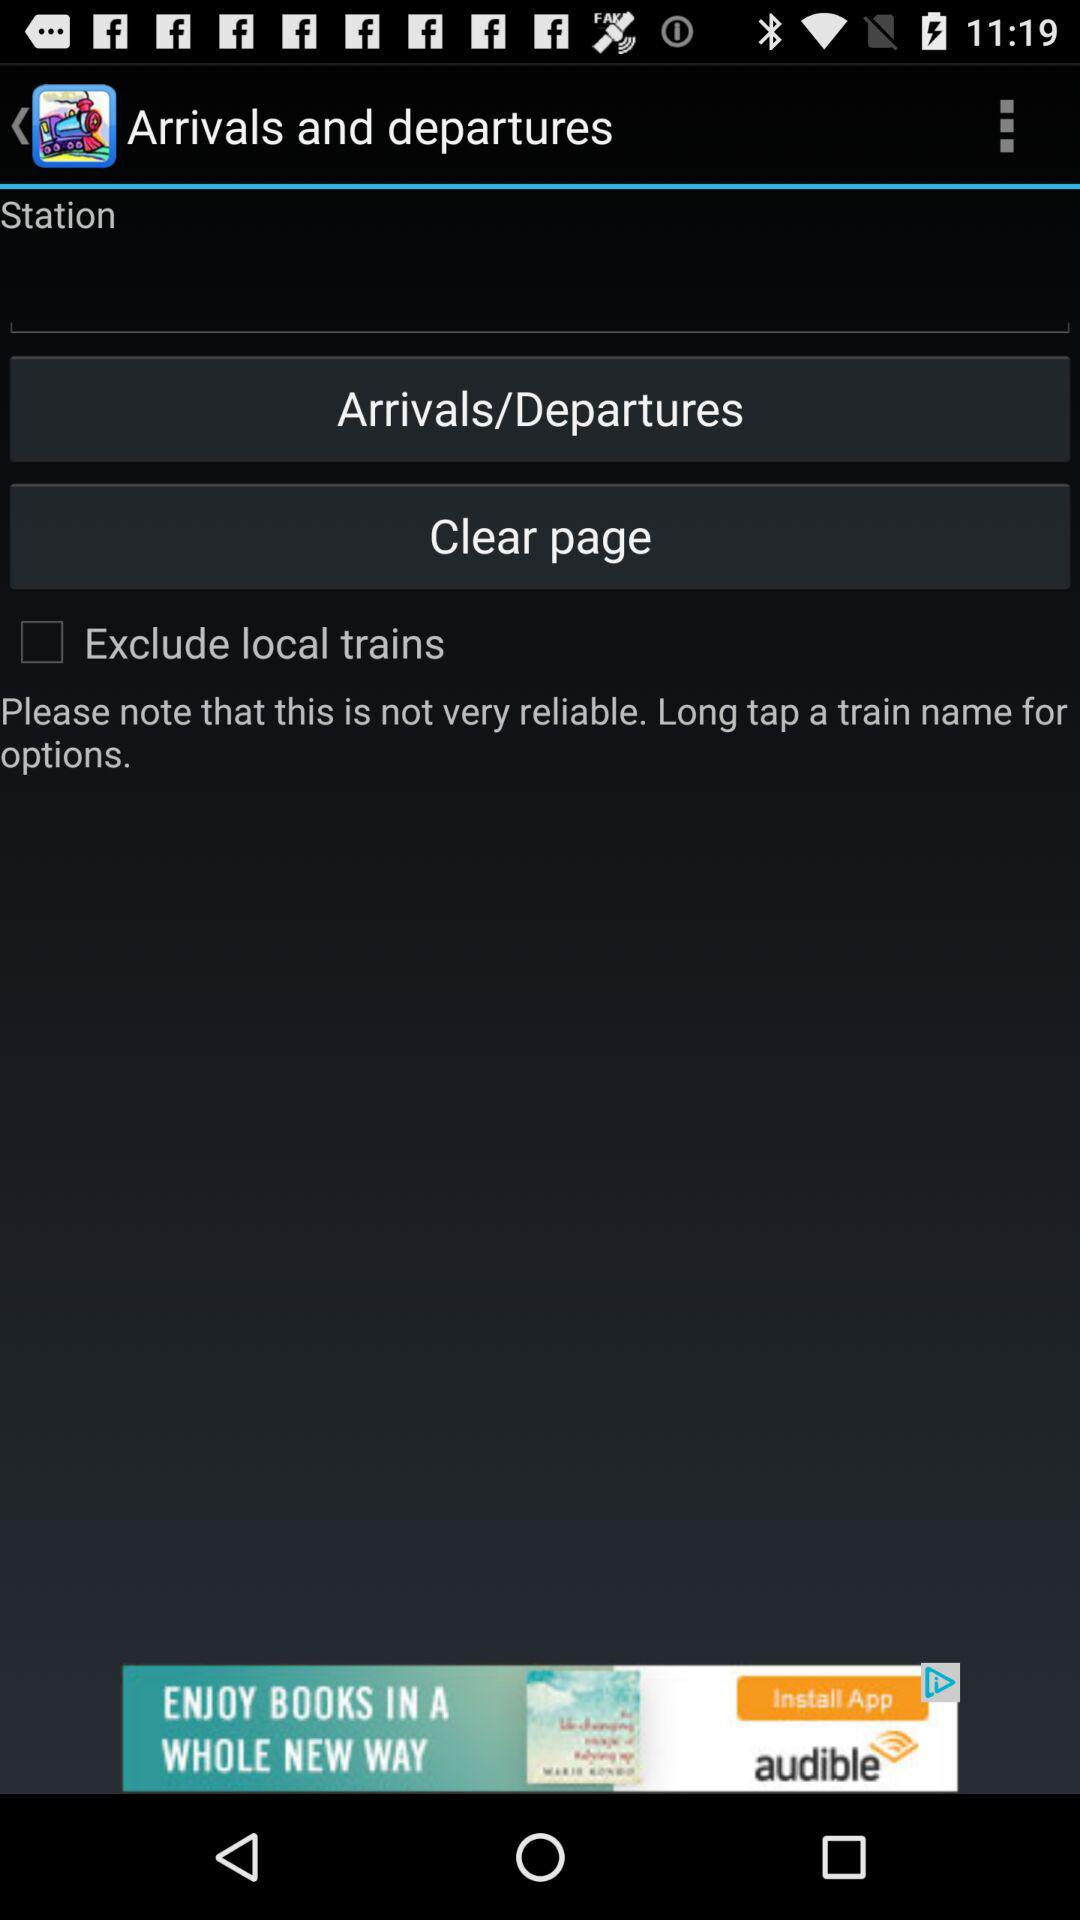What's the status of "Exclude local trains"? The status is "off". 